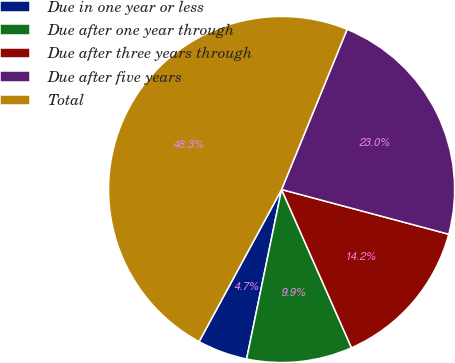Convert chart. <chart><loc_0><loc_0><loc_500><loc_500><pie_chart><fcel>Due in one year or less<fcel>Due after one year through<fcel>Due after three years through<fcel>Due after five years<fcel>Total<nl><fcel>4.67%<fcel>9.86%<fcel>14.22%<fcel>22.98%<fcel>48.27%<nl></chart> 